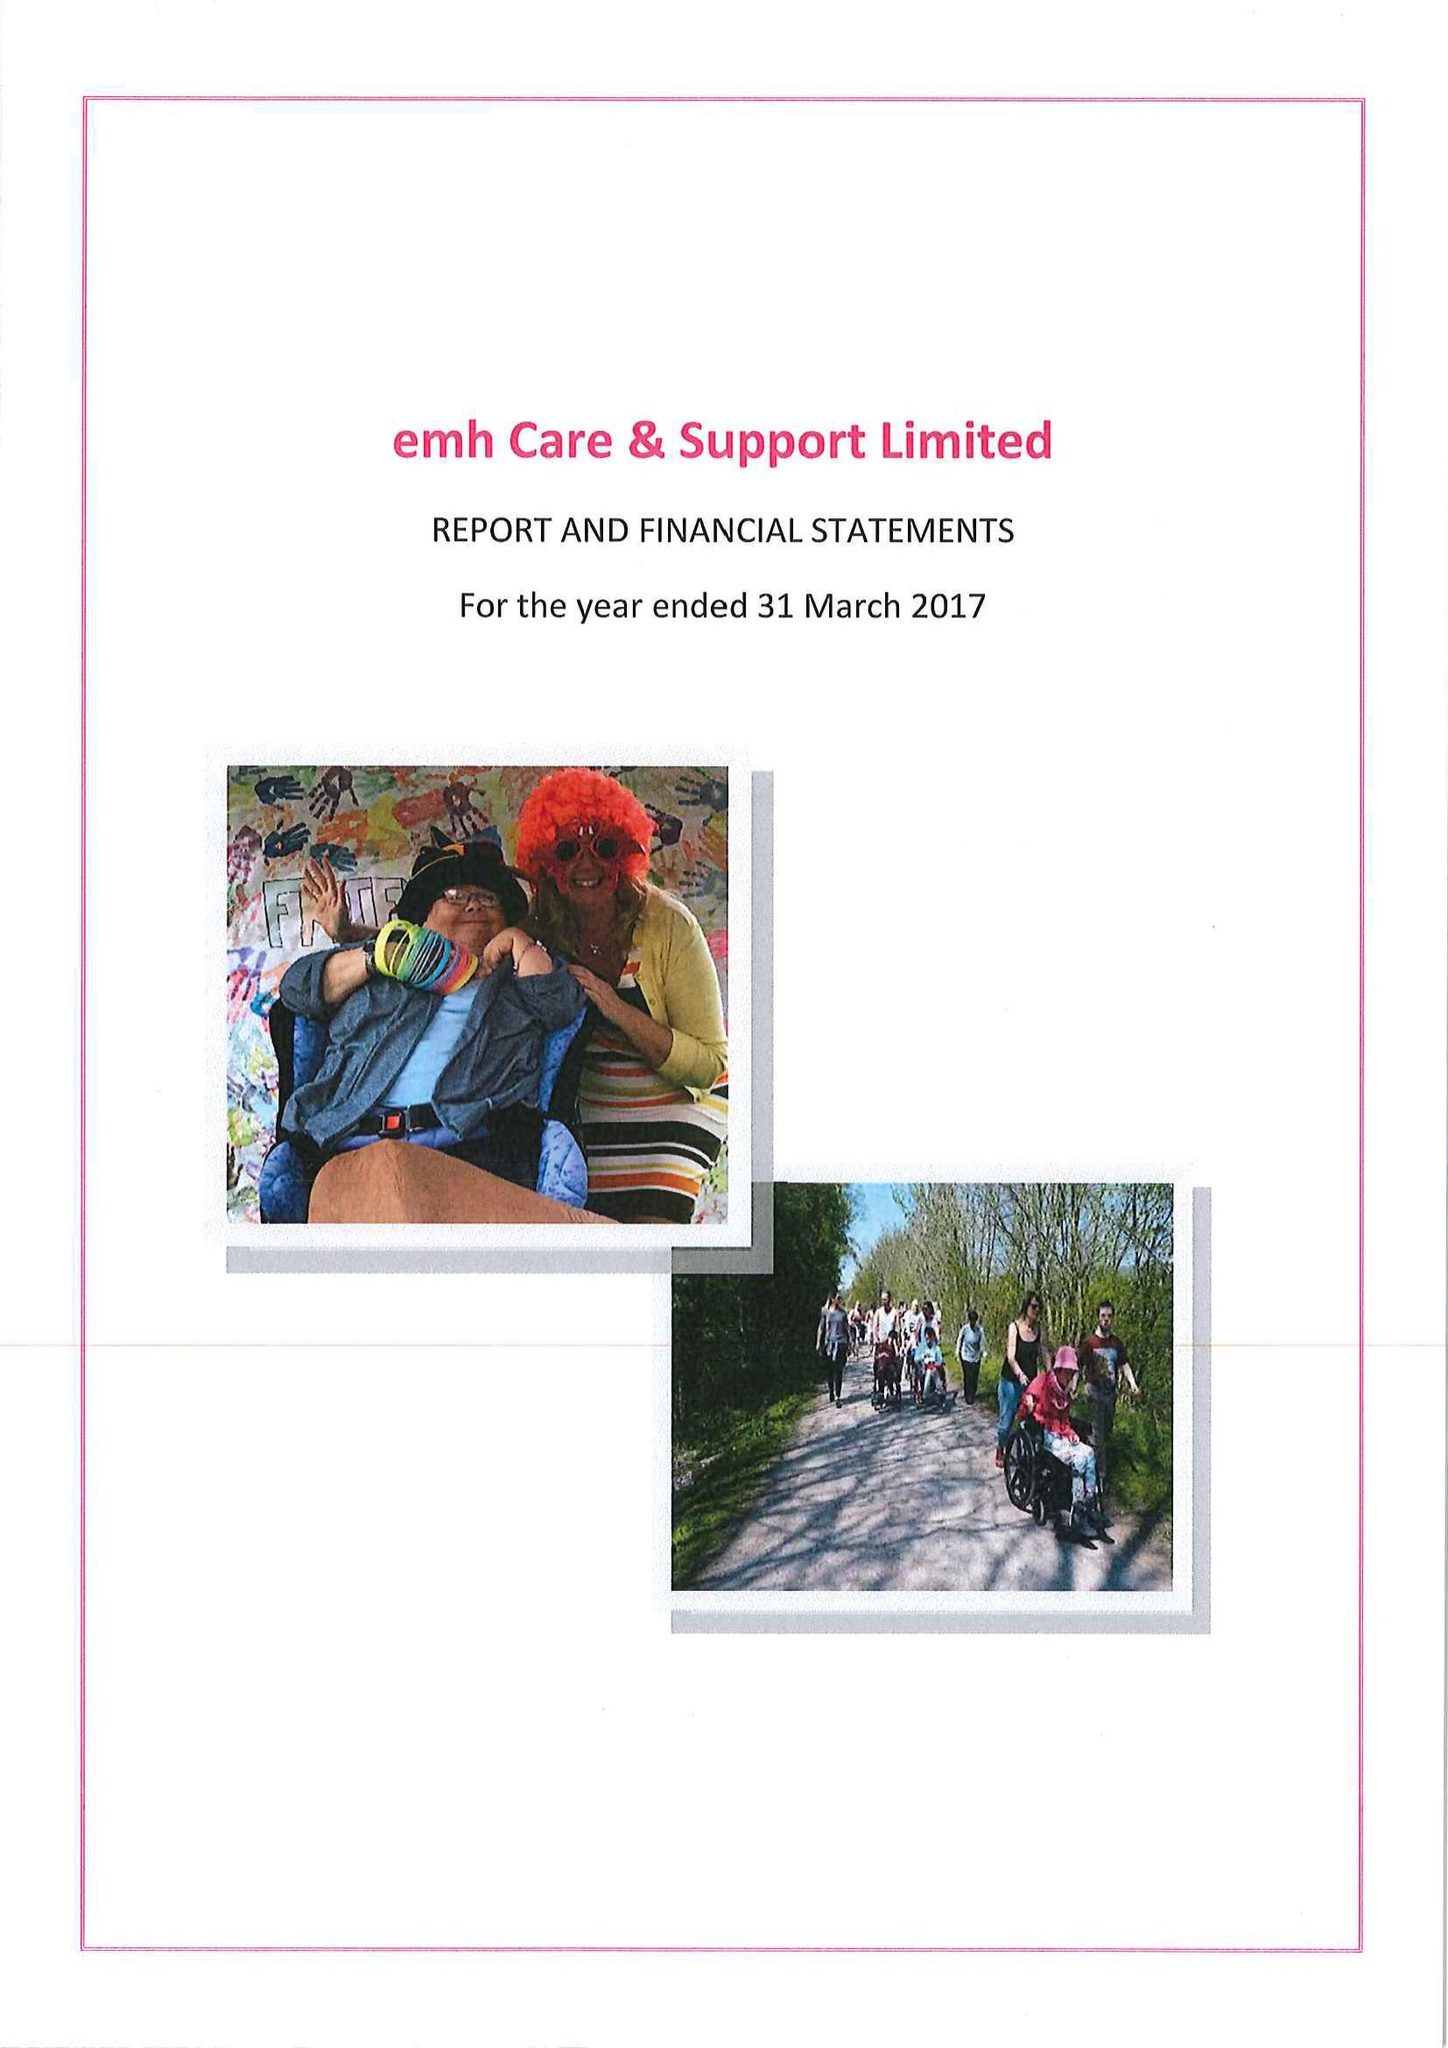What is the value for the address__street_line?
Answer the question using a single word or phrase. STENSON ROAD 